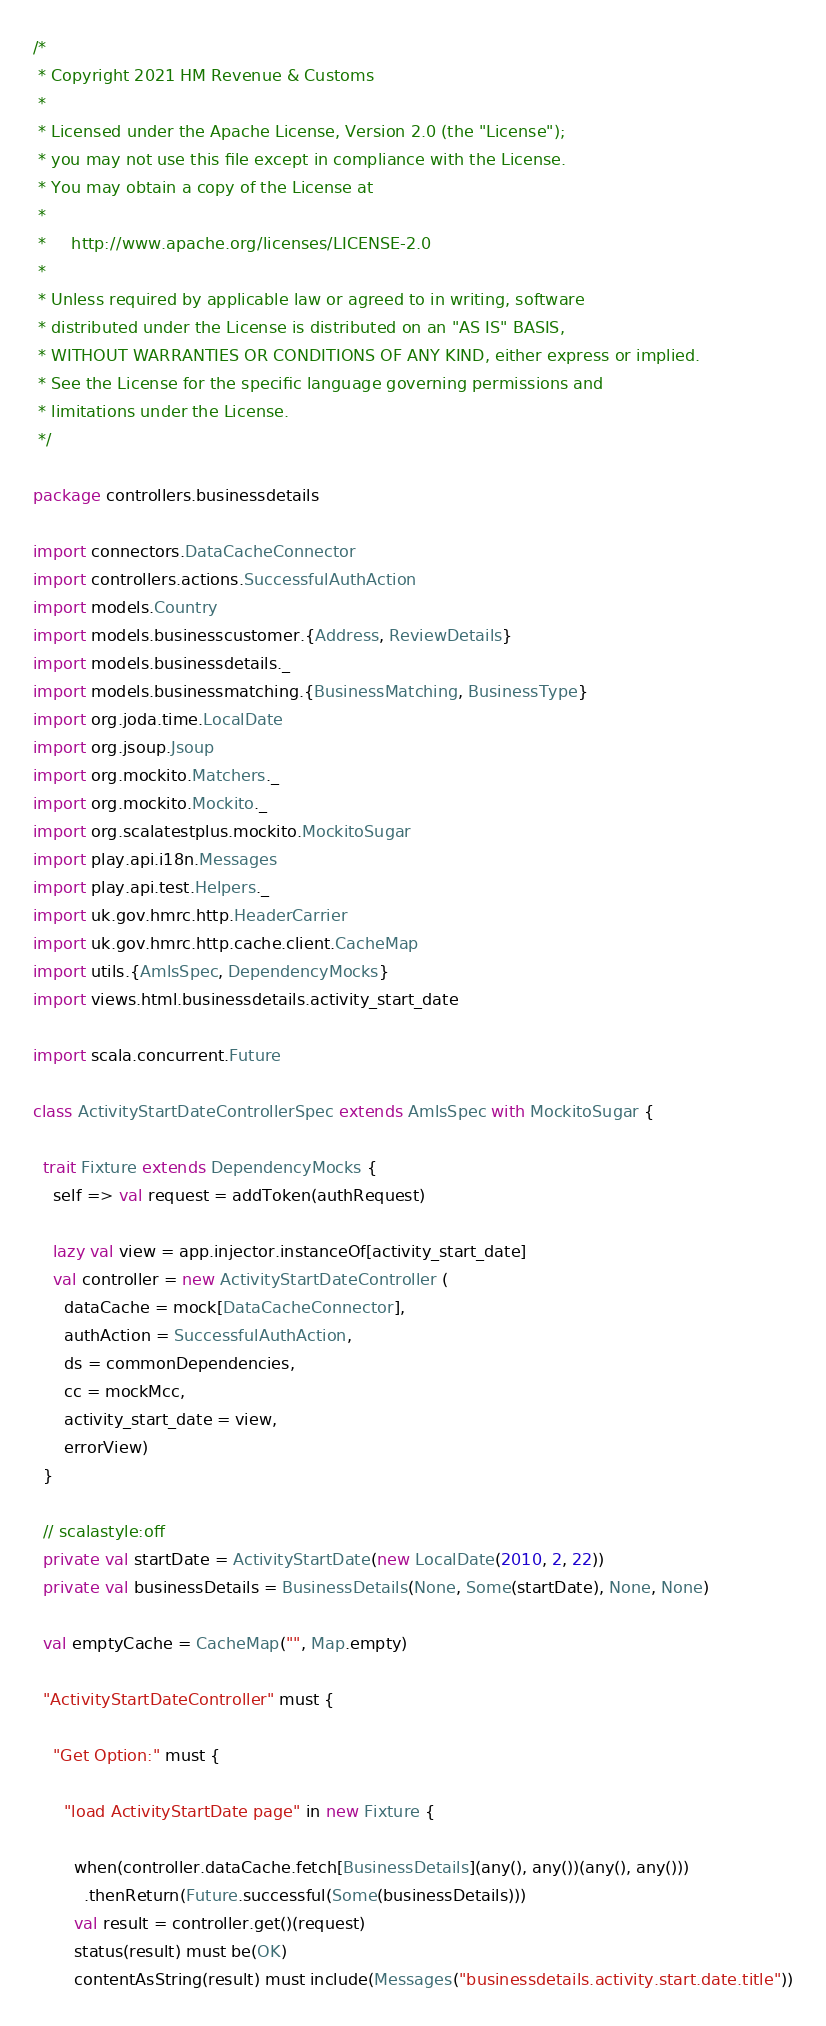Convert code to text. <code><loc_0><loc_0><loc_500><loc_500><_Scala_>/*
 * Copyright 2021 HM Revenue & Customs
 *
 * Licensed under the Apache License, Version 2.0 (the "License");
 * you may not use this file except in compliance with the License.
 * You may obtain a copy of the License at
 *
 *     http://www.apache.org/licenses/LICENSE-2.0
 *
 * Unless required by applicable law or agreed to in writing, software
 * distributed under the License is distributed on an "AS IS" BASIS,
 * WITHOUT WARRANTIES OR CONDITIONS OF ANY KIND, either express or implied.
 * See the License for the specific language governing permissions and
 * limitations under the License.
 */

package controllers.businessdetails

import connectors.DataCacheConnector
import controllers.actions.SuccessfulAuthAction
import models.Country
import models.businesscustomer.{Address, ReviewDetails}
import models.businessdetails._
import models.businessmatching.{BusinessMatching, BusinessType}
import org.joda.time.LocalDate
import org.jsoup.Jsoup
import org.mockito.Matchers._
import org.mockito.Mockito._
import org.scalatestplus.mockito.MockitoSugar
import play.api.i18n.Messages
import play.api.test.Helpers._
import uk.gov.hmrc.http.HeaderCarrier
import uk.gov.hmrc.http.cache.client.CacheMap
import utils.{AmlsSpec, DependencyMocks}
import views.html.businessdetails.activity_start_date

import scala.concurrent.Future

class ActivityStartDateControllerSpec extends AmlsSpec with MockitoSugar {

  trait Fixture extends DependencyMocks {
    self => val request = addToken(authRequest)

    lazy val view = app.injector.instanceOf[activity_start_date]
    val controller = new ActivityStartDateController (
      dataCache = mock[DataCacheConnector],
      authAction = SuccessfulAuthAction,
      ds = commonDependencies,
      cc = mockMcc,
      activity_start_date = view,
      errorView)
  }

  // scalastyle:off
  private val startDate = ActivityStartDate(new LocalDate(2010, 2, 22))
  private val businessDetails = BusinessDetails(None, Some(startDate), None, None)

  val emptyCache = CacheMap("", Map.empty)

  "ActivityStartDateController" must {

    "Get Option:" must {

      "load ActivityStartDate page" in new Fixture {

        when(controller.dataCache.fetch[BusinessDetails](any(), any())(any(), any()))
          .thenReturn(Future.successful(Some(businessDetails)))
        val result = controller.get()(request)
        status(result) must be(OK)
        contentAsString(result) must include(Messages("businessdetails.activity.start.date.title"))</code> 